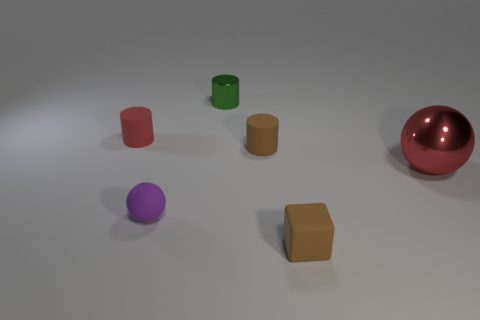Is there a green cylinder?
Offer a terse response. Yes. There is a purple rubber object; is its size the same as the rubber cylinder left of the green thing?
Keep it short and to the point. Yes. There is a red object that is to the right of the green cylinder; are there any matte things that are to the right of it?
Offer a terse response. No. There is a thing that is both in front of the brown cylinder and left of the tiny brown cylinder; what is its material?
Your answer should be very brief. Rubber. There is a tiny sphere in front of the brown rubber object behind the ball behind the tiny matte ball; what is its color?
Your answer should be compact. Purple. What color is the sphere that is the same size as the green cylinder?
Your response must be concise. Purple. There is a big thing; does it have the same color as the sphere that is on the left side of the metal ball?
Your answer should be very brief. No. What material is the brown thing left of the brown rubber object in front of the red sphere?
Ensure brevity in your answer.  Rubber. How many matte things are left of the tiny shiny thing and right of the small red matte thing?
Your answer should be compact. 1. What number of other things are the same size as the green cylinder?
Offer a terse response. 4. 